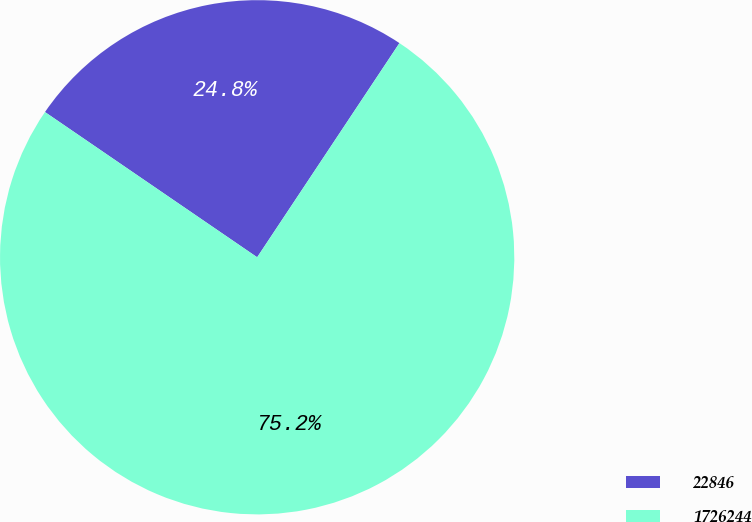<chart> <loc_0><loc_0><loc_500><loc_500><pie_chart><fcel>22846<fcel>1726244<nl><fcel>24.78%<fcel>75.22%<nl></chart> 